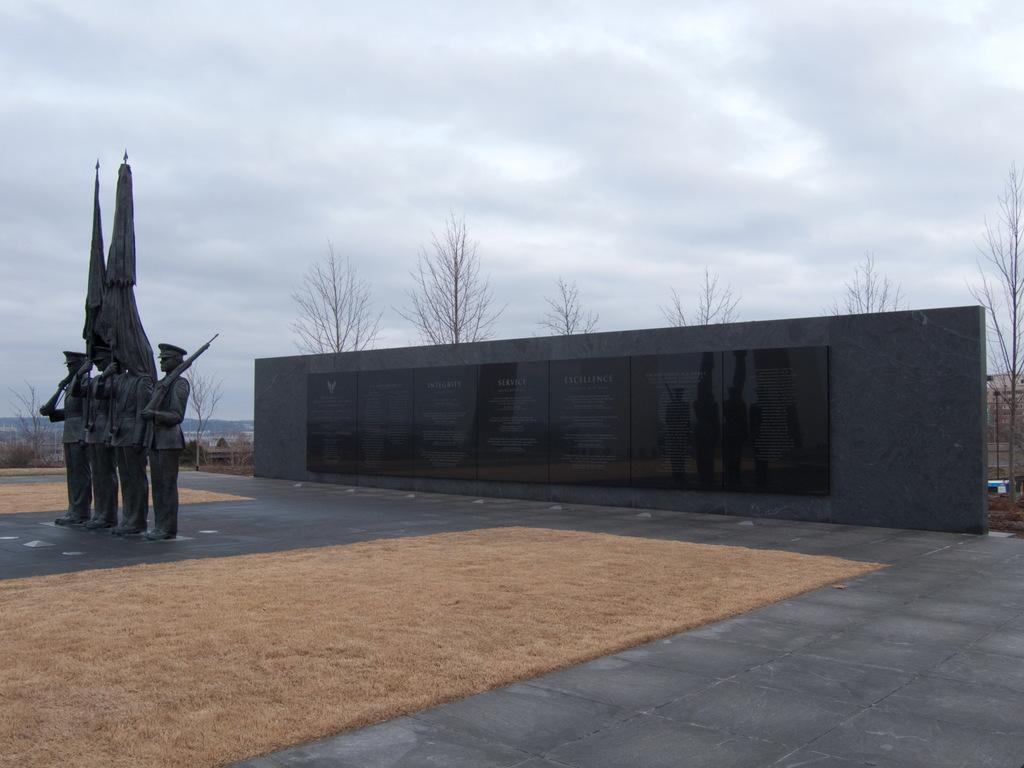Could you give a brief overview of what you see in this image? In this image I can see the statues of the people holding the guns and flags. In the background I can see the board to the wall. I can also see many trees, clouds and the sky in the back. 